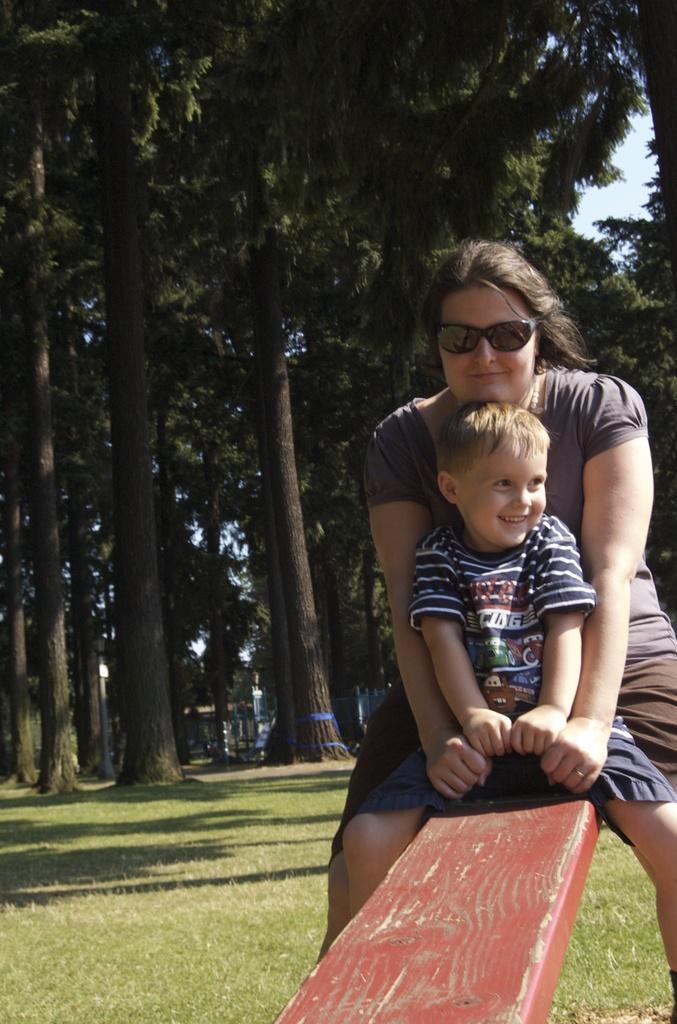Describe this image in one or two sentences. In this picture there is a woman and there is a boy sitting on the seesaw and smiling. At the back there are trees and their might be a building. At the top there is sky. At the bottom there is grass. 